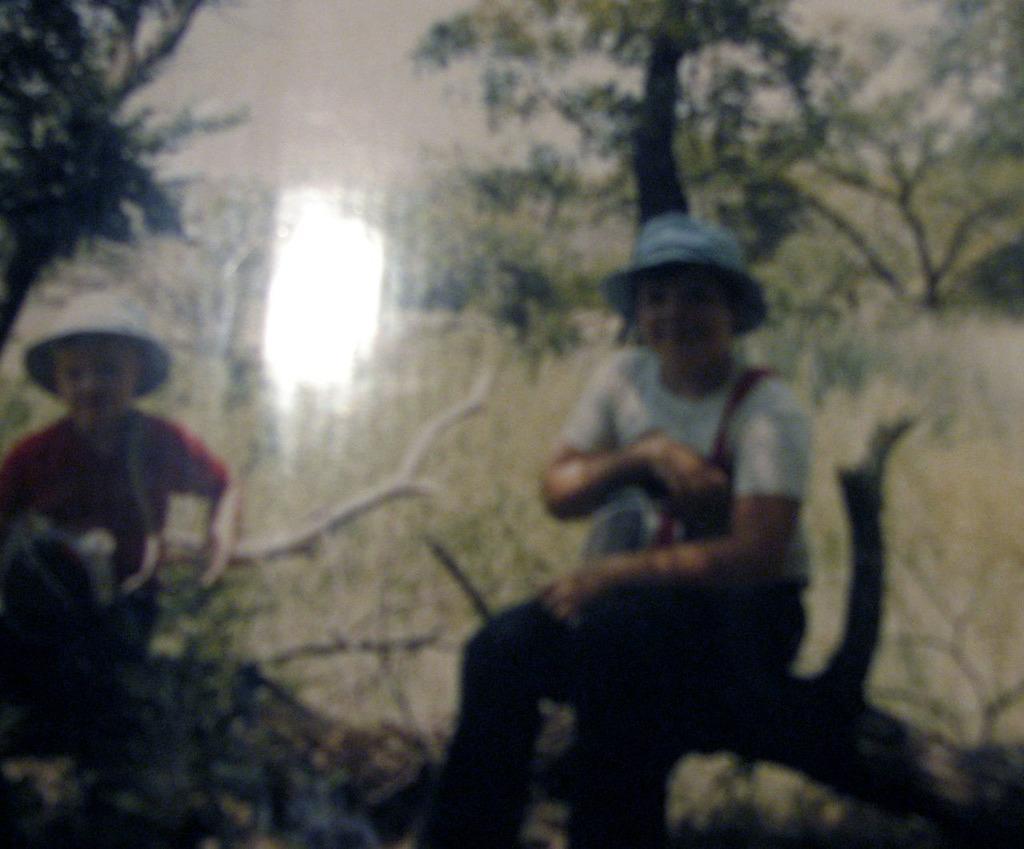Can you describe this image briefly? In this image there are two people sitting on the branch of a tree, behind them there are trees. 